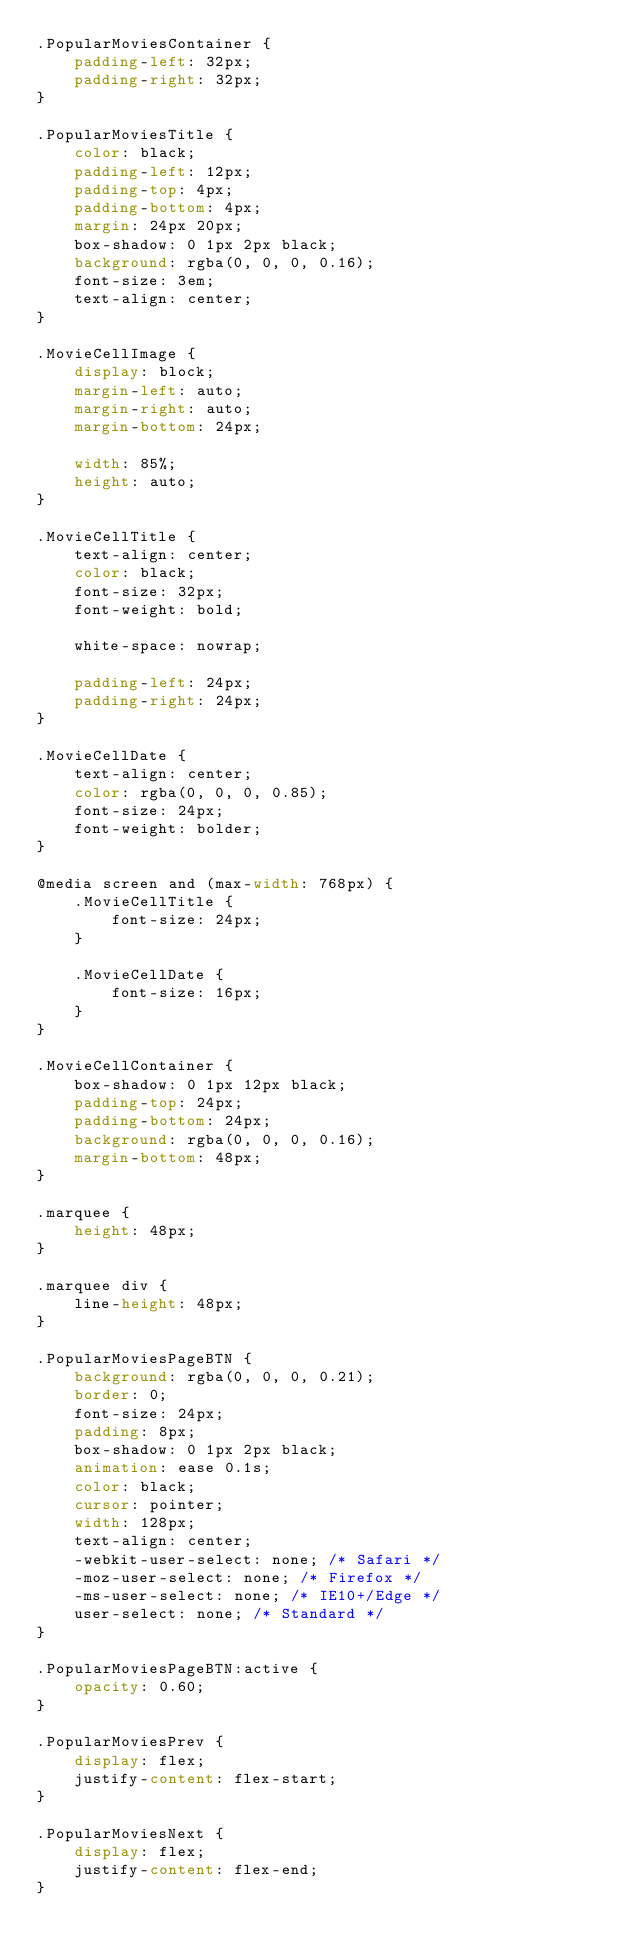Convert code to text. <code><loc_0><loc_0><loc_500><loc_500><_CSS_>.PopularMoviesContainer {
    padding-left: 32px;
    padding-right: 32px;
}

.PopularMoviesTitle {
    color: black;
    padding-left: 12px;
    padding-top: 4px;
    padding-bottom: 4px;
    margin: 24px 20px;
    box-shadow: 0 1px 2px black;
    background: rgba(0, 0, 0, 0.16);
    font-size: 3em;
    text-align: center;
}

.MovieCellImage {
    display: block;
    margin-left: auto;
    margin-right: auto;
    margin-bottom: 24px;

    width: 85%;
    height: auto;
}

.MovieCellTitle {
    text-align: center;
    color: black;
    font-size: 32px;
    font-weight: bold;

    white-space: nowrap;

    padding-left: 24px;
    padding-right: 24px;
}

.MovieCellDate {
    text-align: center;
    color: rgba(0, 0, 0, 0.85);
    font-size: 24px;
    font-weight: bolder;
}

@media screen and (max-width: 768px) {
    .MovieCellTitle {
        font-size: 24px;
    }

    .MovieCellDate {
        font-size: 16px;
    }
}

.MovieCellContainer {
    box-shadow: 0 1px 12px black;
    padding-top: 24px;
    padding-bottom: 24px;
    background: rgba(0, 0, 0, 0.16);
    margin-bottom: 48px;
}

.marquee {
    height: 48px;
}

.marquee div {
    line-height: 48px;
}

.PopularMoviesPageBTN {
    background: rgba(0, 0, 0, 0.21);
    border: 0;
    font-size: 24px;
    padding: 8px;
    box-shadow: 0 1px 2px black;
    animation: ease 0.1s;
    color: black;
    cursor: pointer;
    width: 128px;
    text-align: center;
    -webkit-user-select: none; /* Safari */
    -moz-user-select: none; /* Firefox */
    -ms-user-select: none; /* IE10+/Edge */
    user-select: none; /* Standard */
}

.PopularMoviesPageBTN:active {
    opacity: 0.60;
}

.PopularMoviesPrev {
    display: flex;
    justify-content: flex-start;
}

.PopularMoviesNext {
    display: flex;
    justify-content: flex-end;
}</code> 